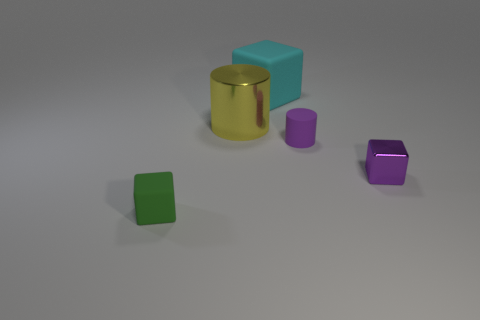Add 2 large brown matte spheres. How many objects exist? 7 Subtract all cylinders. How many objects are left? 3 Add 1 yellow cylinders. How many yellow cylinders are left? 2 Add 1 big blue things. How many big blue things exist? 1 Subtract 0 yellow spheres. How many objects are left? 5 Subtract all purple cubes. Subtract all large matte blocks. How many objects are left? 3 